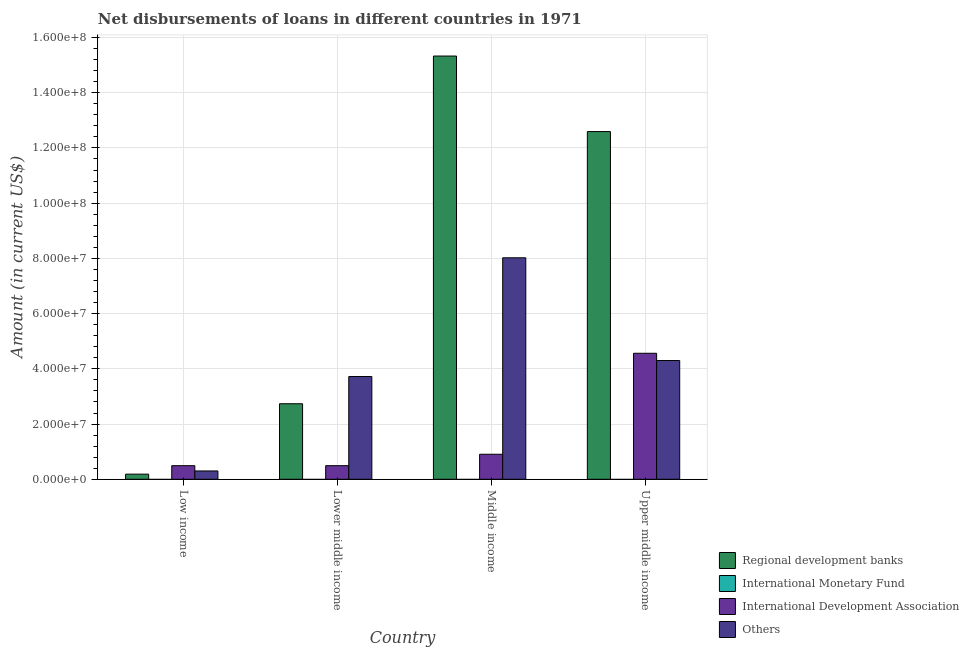How many different coloured bars are there?
Offer a terse response. 3. How many bars are there on the 2nd tick from the left?
Offer a terse response. 3. How many bars are there on the 4th tick from the right?
Your answer should be very brief. 3. What is the label of the 4th group of bars from the left?
Ensure brevity in your answer.  Upper middle income. What is the amount of loan disimbursed by regional development banks in Upper middle income?
Your response must be concise. 1.26e+08. Across all countries, what is the maximum amount of loan disimbursed by international development association?
Keep it short and to the point. 4.56e+07. Across all countries, what is the minimum amount of loan disimbursed by international development association?
Provide a short and direct response. 4.92e+06. In which country was the amount of loan disimbursed by regional development banks maximum?
Provide a short and direct response. Middle income. What is the total amount of loan disimbursed by regional development banks in the graph?
Give a very brief answer. 3.08e+08. What is the difference between the amount of loan disimbursed by regional development banks in Low income and that in Lower middle income?
Provide a short and direct response. -2.55e+07. What is the difference between the amount of loan disimbursed by international development association in Lower middle income and the amount of loan disimbursed by regional development banks in Low income?
Your response must be concise. 3.06e+06. What is the average amount of loan disimbursed by regional development banks per country?
Your response must be concise. 7.71e+07. What is the difference between the amount of loan disimbursed by other organisations and amount of loan disimbursed by regional development banks in Upper middle income?
Your response must be concise. -8.29e+07. What is the ratio of the amount of loan disimbursed by other organisations in Lower middle income to that in Middle income?
Offer a terse response. 0.46. Is the amount of loan disimbursed by other organisations in Low income less than that in Upper middle income?
Your response must be concise. Yes. Is the difference between the amount of loan disimbursed by international development association in Lower middle income and Middle income greater than the difference between the amount of loan disimbursed by regional development banks in Lower middle income and Middle income?
Give a very brief answer. Yes. What is the difference between the highest and the second highest amount of loan disimbursed by other organisations?
Your response must be concise. 3.72e+07. What is the difference between the highest and the lowest amount of loan disimbursed by international development association?
Offer a terse response. 4.07e+07. Is the sum of the amount of loan disimbursed by international development association in Low income and Upper middle income greater than the maximum amount of loan disimbursed by other organisations across all countries?
Provide a short and direct response. No. Is it the case that in every country, the sum of the amount of loan disimbursed by international monetary fund and amount of loan disimbursed by international development association is greater than the sum of amount of loan disimbursed by regional development banks and amount of loan disimbursed by other organisations?
Keep it short and to the point. No. Are all the bars in the graph horizontal?
Make the answer very short. No. How many countries are there in the graph?
Your answer should be very brief. 4. What is the difference between two consecutive major ticks on the Y-axis?
Your answer should be compact. 2.00e+07. How many legend labels are there?
Ensure brevity in your answer.  4. What is the title of the graph?
Your response must be concise. Net disbursements of loans in different countries in 1971. What is the Amount (in current US$) of Regional development banks in Low income?
Provide a succinct answer. 1.86e+06. What is the Amount (in current US$) of International Development Association in Low income?
Offer a terse response. 4.92e+06. What is the Amount (in current US$) in Others in Low income?
Give a very brief answer. 3.02e+06. What is the Amount (in current US$) of Regional development banks in Lower middle income?
Make the answer very short. 2.74e+07. What is the Amount (in current US$) in International Monetary Fund in Lower middle income?
Provide a succinct answer. 0. What is the Amount (in current US$) of International Development Association in Lower middle income?
Make the answer very short. 4.92e+06. What is the Amount (in current US$) in Others in Lower middle income?
Your answer should be compact. 3.72e+07. What is the Amount (in current US$) in Regional development banks in Middle income?
Your answer should be very brief. 1.53e+08. What is the Amount (in current US$) in International Development Association in Middle income?
Make the answer very short. 9.06e+06. What is the Amount (in current US$) of Others in Middle income?
Your response must be concise. 8.02e+07. What is the Amount (in current US$) in Regional development banks in Upper middle income?
Make the answer very short. 1.26e+08. What is the Amount (in current US$) in International Development Association in Upper middle income?
Keep it short and to the point. 4.56e+07. What is the Amount (in current US$) of Others in Upper middle income?
Provide a succinct answer. 4.30e+07. Across all countries, what is the maximum Amount (in current US$) of Regional development banks?
Offer a very short reply. 1.53e+08. Across all countries, what is the maximum Amount (in current US$) in International Development Association?
Your response must be concise. 4.56e+07. Across all countries, what is the maximum Amount (in current US$) in Others?
Give a very brief answer. 8.02e+07. Across all countries, what is the minimum Amount (in current US$) in Regional development banks?
Ensure brevity in your answer.  1.86e+06. Across all countries, what is the minimum Amount (in current US$) in International Development Association?
Your answer should be compact. 4.92e+06. Across all countries, what is the minimum Amount (in current US$) in Others?
Provide a short and direct response. 3.02e+06. What is the total Amount (in current US$) of Regional development banks in the graph?
Offer a very short reply. 3.08e+08. What is the total Amount (in current US$) in International Monetary Fund in the graph?
Make the answer very short. 0. What is the total Amount (in current US$) in International Development Association in the graph?
Your answer should be very brief. 6.45e+07. What is the total Amount (in current US$) in Others in the graph?
Ensure brevity in your answer.  1.63e+08. What is the difference between the Amount (in current US$) of Regional development banks in Low income and that in Lower middle income?
Provide a succinct answer. -2.55e+07. What is the difference between the Amount (in current US$) in Others in Low income and that in Lower middle income?
Your answer should be compact. -3.42e+07. What is the difference between the Amount (in current US$) in Regional development banks in Low income and that in Middle income?
Make the answer very short. -1.51e+08. What is the difference between the Amount (in current US$) in International Development Association in Low income and that in Middle income?
Your response must be concise. -4.14e+06. What is the difference between the Amount (in current US$) of Others in Low income and that in Middle income?
Offer a terse response. -7.72e+07. What is the difference between the Amount (in current US$) of Regional development banks in Low income and that in Upper middle income?
Make the answer very short. -1.24e+08. What is the difference between the Amount (in current US$) in International Development Association in Low income and that in Upper middle income?
Give a very brief answer. -4.07e+07. What is the difference between the Amount (in current US$) of Others in Low income and that in Upper middle income?
Your answer should be very brief. -4.00e+07. What is the difference between the Amount (in current US$) of Regional development banks in Lower middle income and that in Middle income?
Offer a very short reply. -1.26e+08. What is the difference between the Amount (in current US$) in International Development Association in Lower middle income and that in Middle income?
Your response must be concise. -4.14e+06. What is the difference between the Amount (in current US$) of Others in Lower middle income and that in Middle income?
Your answer should be very brief. -4.30e+07. What is the difference between the Amount (in current US$) in Regional development banks in Lower middle income and that in Upper middle income?
Your response must be concise. -9.86e+07. What is the difference between the Amount (in current US$) in International Development Association in Lower middle income and that in Upper middle income?
Provide a succinct answer. -4.07e+07. What is the difference between the Amount (in current US$) of Others in Lower middle income and that in Upper middle income?
Your response must be concise. -5.79e+06. What is the difference between the Amount (in current US$) in Regional development banks in Middle income and that in Upper middle income?
Ensure brevity in your answer.  2.74e+07. What is the difference between the Amount (in current US$) in International Development Association in Middle income and that in Upper middle income?
Keep it short and to the point. -3.66e+07. What is the difference between the Amount (in current US$) of Others in Middle income and that in Upper middle income?
Give a very brief answer. 3.72e+07. What is the difference between the Amount (in current US$) in Regional development banks in Low income and the Amount (in current US$) in International Development Association in Lower middle income?
Your answer should be compact. -3.06e+06. What is the difference between the Amount (in current US$) of Regional development banks in Low income and the Amount (in current US$) of Others in Lower middle income?
Offer a very short reply. -3.54e+07. What is the difference between the Amount (in current US$) in International Development Association in Low income and the Amount (in current US$) in Others in Lower middle income?
Offer a terse response. -3.23e+07. What is the difference between the Amount (in current US$) of Regional development banks in Low income and the Amount (in current US$) of International Development Association in Middle income?
Your response must be concise. -7.20e+06. What is the difference between the Amount (in current US$) in Regional development banks in Low income and the Amount (in current US$) in Others in Middle income?
Keep it short and to the point. -7.83e+07. What is the difference between the Amount (in current US$) of International Development Association in Low income and the Amount (in current US$) of Others in Middle income?
Your answer should be compact. -7.53e+07. What is the difference between the Amount (in current US$) in Regional development banks in Low income and the Amount (in current US$) in International Development Association in Upper middle income?
Your answer should be very brief. -4.38e+07. What is the difference between the Amount (in current US$) of Regional development banks in Low income and the Amount (in current US$) of Others in Upper middle income?
Provide a short and direct response. -4.11e+07. What is the difference between the Amount (in current US$) of International Development Association in Low income and the Amount (in current US$) of Others in Upper middle income?
Your response must be concise. -3.81e+07. What is the difference between the Amount (in current US$) in Regional development banks in Lower middle income and the Amount (in current US$) in International Development Association in Middle income?
Offer a terse response. 1.83e+07. What is the difference between the Amount (in current US$) of Regional development banks in Lower middle income and the Amount (in current US$) of Others in Middle income?
Make the answer very short. -5.29e+07. What is the difference between the Amount (in current US$) in International Development Association in Lower middle income and the Amount (in current US$) in Others in Middle income?
Ensure brevity in your answer.  -7.53e+07. What is the difference between the Amount (in current US$) in Regional development banks in Lower middle income and the Amount (in current US$) in International Development Association in Upper middle income?
Your response must be concise. -1.83e+07. What is the difference between the Amount (in current US$) of Regional development banks in Lower middle income and the Amount (in current US$) of Others in Upper middle income?
Your answer should be compact. -1.56e+07. What is the difference between the Amount (in current US$) in International Development Association in Lower middle income and the Amount (in current US$) in Others in Upper middle income?
Your response must be concise. -3.81e+07. What is the difference between the Amount (in current US$) of Regional development banks in Middle income and the Amount (in current US$) of International Development Association in Upper middle income?
Provide a short and direct response. 1.08e+08. What is the difference between the Amount (in current US$) in Regional development banks in Middle income and the Amount (in current US$) in Others in Upper middle income?
Keep it short and to the point. 1.10e+08. What is the difference between the Amount (in current US$) of International Development Association in Middle income and the Amount (in current US$) of Others in Upper middle income?
Offer a very short reply. -3.39e+07. What is the average Amount (in current US$) of Regional development banks per country?
Provide a short and direct response. 7.71e+07. What is the average Amount (in current US$) of International Development Association per country?
Make the answer very short. 1.61e+07. What is the average Amount (in current US$) in Others per country?
Ensure brevity in your answer.  4.09e+07. What is the difference between the Amount (in current US$) of Regional development banks and Amount (in current US$) of International Development Association in Low income?
Provide a short and direct response. -3.06e+06. What is the difference between the Amount (in current US$) in Regional development banks and Amount (in current US$) in Others in Low income?
Provide a succinct answer. -1.16e+06. What is the difference between the Amount (in current US$) in International Development Association and Amount (in current US$) in Others in Low income?
Make the answer very short. 1.91e+06. What is the difference between the Amount (in current US$) in Regional development banks and Amount (in current US$) in International Development Association in Lower middle income?
Your response must be concise. 2.24e+07. What is the difference between the Amount (in current US$) of Regional development banks and Amount (in current US$) of Others in Lower middle income?
Your answer should be very brief. -9.86e+06. What is the difference between the Amount (in current US$) of International Development Association and Amount (in current US$) of Others in Lower middle income?
Give a very brief answer. -3.23e+07. What is the difference between the Amount (in current US$) of Regional development banks and Amount (in current US$) of International Development Association in Middle income?
Provide a succinct answer. 1.44e+08. What is the difference between the Amount (in current US$) of Regional development banks and Amount (in current US$) of Others in Middle income?
Your answer should be compact. 7.31e+07. What is the difference between the Amount (in current US$) in International Development Association and Amount (in current US$) in Others in Middle income?
Your answer should be very brief. -7.11e+07. What is the difference between the Amount (in current US$) in Regional development banks and Amount (in current US$) in International Development Association in Upper middle income?
Provide a short and direct response. 8.03e+07. What is the difference between the Amount (in current US$) of Regional development banks and Amount (in current US$) of Others in Upper middle income?
Offer a very short reply. 8.29e+07. What is the difference between the Amount (in current US$) in International Development Association and Amount (in current US$) in Others in Upper middle income?
Your answer should be compact. 2.63e+06. What is the ratio of the Amount (in current US$) in Regional development banks in Low income to that in Lower middle income?
Your response must be concise. 0.07. What is the ratio of the Amount (in current US$) of International Development Association in Low income to that in Lower middle income?
Your response must be concise. 1. What is the ratio of the Amount (in current US$) in Others in Low income to that in Lower middle income?
Offer a very short reply. 0.08. What is the ratio of the Amount (in current US$) of Regional development banks in Low income to that in Middle income?
Make the answer very short. 0.01. What is the ratio of the Amount (in current US$) of International Development Association in Low income to that in Middle income?
Make the answer very short. 0.54. What is the ratio of the Amount (in current US$) of Others in Low income to that in Middle income?
Provide a succinct answer. 0.04. What is the ratio of the Amount (in current US$) of Regional development banks in Low income to that in Upper middle income?
Your answer should be very brief. 0.01. What is the ratio of the Amount (in current US$) in International Development Association in Low income to that in Upper middle income?
Provide a succinct answer. 0.11. What is the ratio of the Amount (in current US$) of Others in Low income to that in Upper middle income?
Keep it short and to the point. 0.07. What is the ratio of the Amount (in current US$) of Regional development banks in Lower middle income to that in Middle income?
Provide a succinct answer. 0.18. What is the ratio of the Amount (in current US$) of International Development Association in Lower middle income to that in Middle income?
Provide a succinct answer. 0.54. What is the ratio of the Amount (in current US$) of Others in Lower middle income to that in Middle income?
Offer a very short reply. 0.46. What is the ratio of the Amount (in current US$) of Regional development banks in Lower middle income to that in Upper middle income?
Your answer should be very brief. 0.22. What is the ratio of the Amount (in current US$) of International Development Association in Lower middle income to that in Upper middle income?
Your response must be concise. 0.11. What is the ratio of the Amount (in current US$) of Others in Lower middle income to that in Upper middle income?
Ensure brevity in your answer.  0.87. What is the ratio of the Amount (in current US$) in Regional development banks in Middle income to that in Upper middle income?
Provide a short and direct response. 1.22. What is the ratio of the Amount (in current US$) of International Development Association in Middle income to that in Upper middle income?
Your answer should be very brief. 0.2. What is the ratio of the Amount (in current US$) in Others in Middle income to that in Upper middle income?
Your response must be concise. 1.87. What is the difference between the highest and the second highest Amount (in current US$) in Regional development banks?
Your answer should be compact. 2.74e+07. What is the difference between the highest and the second highest Amount (in current US$) in International Development Association?
Offer a very short reply. 3.66e+07. What is the difference between the highest and the second highest Amount (in current US$) of Others?
Ensure brevity in your answer.  3.72e+07. What is the difference between the highest and the lowest Amount (in current US$) in Regional development banks?
Ensure brevity in your answer.  1.51e+08. What is the difference between the highest and the lowest Amount (in current US$) of International Development Association?
Provide a succinct answer. 4.07e+07. What is the difference between the highest and the lowest Amount (in current US$) of Others?
Your answer should be very brief. 7.72e+07. 